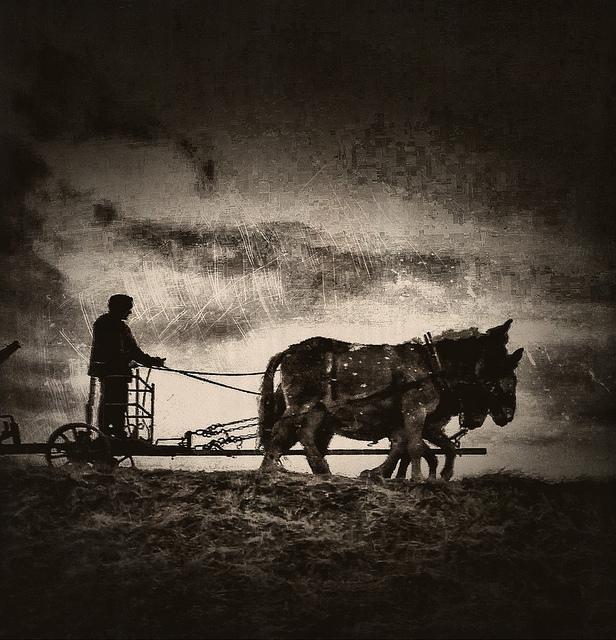How many people are in this scene?
Give a very brief answer. 1. How many horses?
Give a very brief answer. 2. How many horses are in the photo?
Give a very brief answer. 2. 